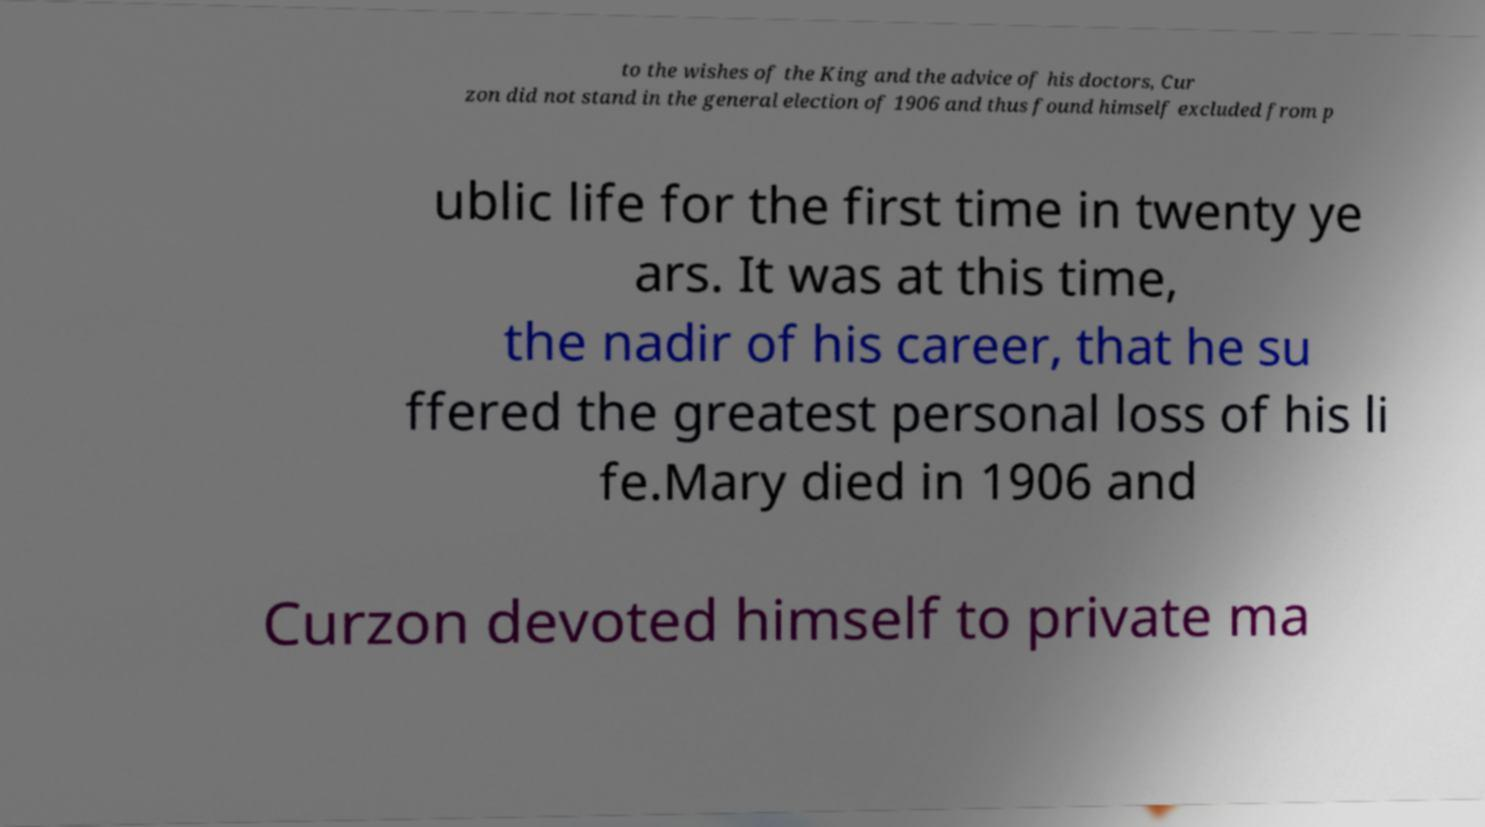Please read and relay the text visible in this image. What does it say? to the wishes of the King and the advice of his doctors, Cur zon did not stand in the general election of 1906 and thus found himself excluded from p ublic life for the first time in twenty ye ars. It was at this time, the nadir of his career, that he su ffered the greatest personal loss of his li fe.Mary died in 1906 and Curzon devoted himself to private ma 